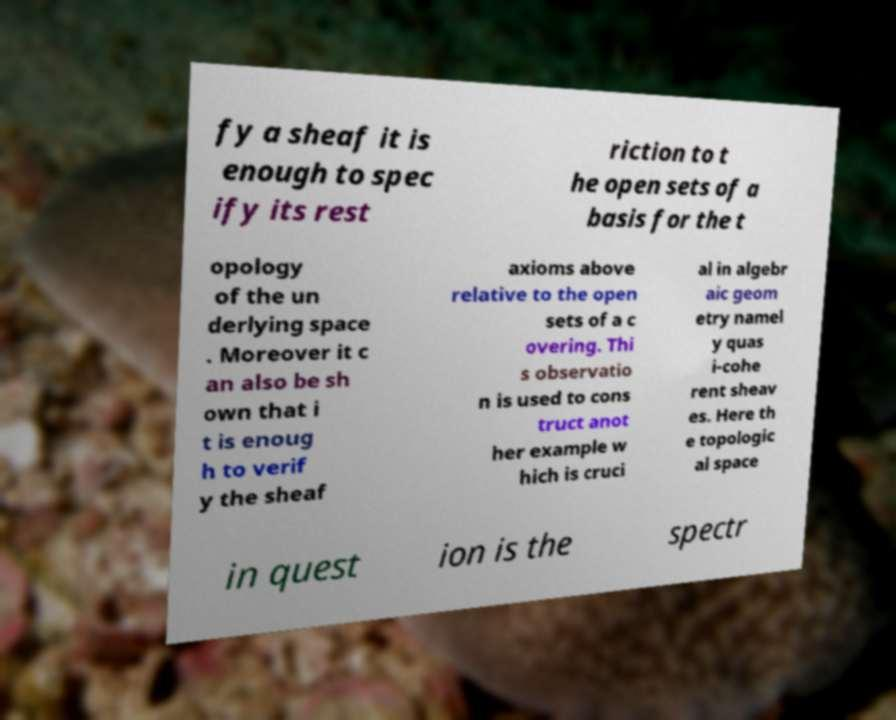Could you extract and type out the text from this image? fy a sheaf it is enough to spec ify its rest riction to t he open sets of a basis for the t opology of the un derlying space . Moreover it c an also be sh own that i t is enoug h to verif y the sheaf axioms above relative to the open sets of a c overing. Thi s observatio n is used to cons truct anot her example w hich is cruci al in algebr aic geom etry namel y quas i-cohe rent sheav es. Here th e topologic al space in quest ion is the spectr 